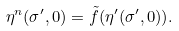Convert formula to latex. <formula><loc_0><loc_0><loc_500><loc_500>\eta ^ { n } ( \sigma ^ { \prime } , 0 ) = \tilde { f } ( \eta ^ { \prime } ( \sigma ^ { \prime } , 0 ) ) .</formula> 